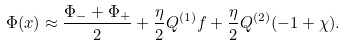Convert formula to latex. <formula><loc_0><loc_0><loc_500><loc_500>\Phi ( x ) \approx \frac { \Phi _ { - } + \Phi _ { + } } { 2 } + \frac { \eta } { 2 } Q ^ { ( 1 ) } f + \frac { \eta } { 2 } Q ^ { ( 2 ) } ( - 1 + \chi ) .</formula> 